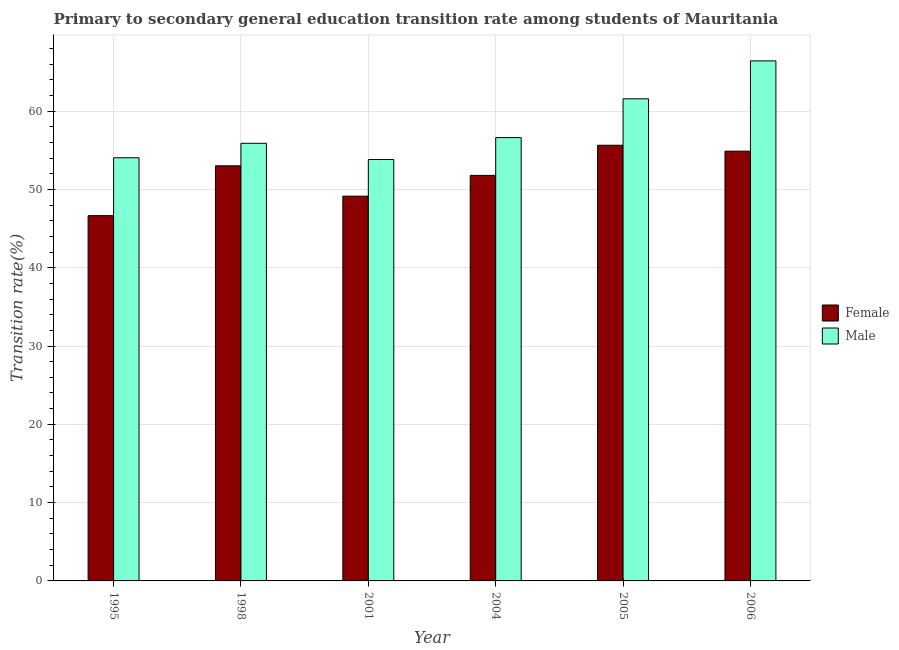How many different coloured bars are there?
Your response must be concise. 2. In how many cases, is the number of bars for a given year not equal to the number of legend labels?
Your answer should be very brief. 0. What is the transition rate among male students in 1998?
Your answer should be compact. 55.89. Across all years, what is the maximum transition rate among male students?
Provide a succinct answer. 66.41. Across all years, what is the minimum transition rate among female students?
Make the answer very short. 46.65. In which year was the transition rate among female students minimum?
Your response must be concise. 1995. What is the total transition rate among female students in the graph?
Provide a short and direct response. 311.11. What is the difference between the transition rate among female students in 2005 and that in 2006?
Keep it short and to the point. 0.76. What is the difference between the transition rate among female students in 2001 and the transition rate among male students in 1998?
Provide a short and direct response. -3.88. What is the average transition rate among female students per year?
Offer a terse response. 51.85. In how many years, is the transition rate among female students greater than 54 %?
Keep it short and to the point. 2. What is the ratio of the transition rate among male students in 1995 to that in 2005?
Provide a short and direct response. 0.88. What is the difference between the highest and the second highest transition rate among female students?
Provide a short and direct response. 0.76. What is the difference between the highest and the lowest transition rate among male students?
Your response must be concise. 12.59. What does the 2nd bar from the left in 2005 represents?
Provide a succinct answer. Male. What does the 2nd bar from the right in 2005 represents?
Offer a very short reply. Female. How many bars are there?
Offer a terse response. 12. What is the difference between two consecutive major ticks on the Y-axis?
Your answer should be very brief. 10. Does the graph contain any zero values?
Provide a succinct answer. No. How many legend labels are there?
Keep it short and to the point. 2. What is the title of the graph?
Your answer should be very brief. Primary to secondary general education transition rate among students of Mauritania. Does "Male labourers" appear as one of the legend labels in the graph?
Offer a terse response. No. What is the label or title of the Y-axis?
Your answer should be very brief. Transition rate(%). What is the Transition rate(%) of Female in 1995?
Offer a very short reply. 46.65. What is the Transition rate(%) in Male in 1995?
Provide a succinct answer. 54.04. What is the Transition rate(%) of Female in 1998?
Your answer should be very brief. 53.01. What is the Transition rate(%) in Male in 1998?
Provide a succinct answer. 55.89. What is the Transition rate(%) of Female in 2001?
Give a very brief answer. 49.14. What is the Transition rate(%) of Male in 2001?
Offer a terse response. 53.82. What is the Transition rate(%) of Female in 2004?
Your answer should be very brief. 51.79. What is the Transition rate(%) of Male in 2004?
Your answer should be compact. 56.62. What is the Transition rate(%) in Female in 2005?
Provide a succinct answer. 55.64. What is the Transition rate(%) of Male in 2005?
Provide a short and direct response. 61.57. What is the Transition rate(%) in Female in 2006?
Your response must be concise. 54.88. What is the Transition rate(%) in Male in 2006?
Your answer should be very brief. 66.41. Across all years, what is the maximum Transition rate(%) in Female?
Provide a succinct answer. 55.64. Across all years, what is the maximum Transition rate(%) in Male?
Your answer should be very brief. 66.41. Across all years, what is the minimum Transition rate(%) of Female?
Give a very brief answer. 46.65. Across all years, what is the minimum Transition rate(%) in Male?
Provide a short and direct response. 53.82. What is the total Transition rate(%) of Female in the graph?
Your answer should be very brief. 311.11. What is the total Transition rate(%) in Male in the graph?
Your answer should be very brief. 348.35. What is the difference between the Transition rate(%) of Female in 1995 and that in 1998?
Provide a succinct answer. -6.36. What is the difference between the Transition rate(%) in Male in 1995 and that in 1998?
Ensure brevity in your answer.  -1.85. What is the difference between the Transition rate(%) of Female in 1995 and that in 2001?
Your response must be concise. -2.49. What is the difference between the Transition rate(%) of Male in 1995 and that in 2001?
Ensure brevity in your answer.  0.22. What is the difference between the Transition rate(%) of Female in 1995 and that in 2004?
Offer a very short reply. -5.14. What is the difference between the Transition rate(%) of Male in 1995 and that in 2004?
Your answer should be very brief. -2.58. What is the difference between the Transition rate(%) in Female in 1995 and that in 2005?
Offer a terse response. -8.99. What is the difference between the Transition rate(%) of Male in 1995 and that in 2005?
Your answer should be compact. -7.53. What is the difference between the Transition rate(%) of Female in 1995 and that in 2006?
Give a very brief answer. -8.23. What is the difference between the Transition rate(%) in Male in 1995 and that in 2006?
Provide a short and direct response. -12.37. What is the difference between the Transition rate(%) of Female in 1998 and that in 2001?
Keep it short and to the point. 3.88. What is the difference between the Transition rate(%) in Male in 1998 and that in 2001?
Give a very brief answer. 2.07. What is the difference between the Transition rate(%) in Female in 1998 and that in 2004?
Make the answer very short. 1.22. What is the difference between the Transition rate(%) of Male in 1998 and that in 2004?
Provide a short and direct response. -0.73. What is the difference between the Transition rate(%) in Female in 1998 and that in 2005?
Your response must be concise. -2.63. What is the difference between the Transition rate(%) of Male in 1998 and that in 2005?
Your response must be concise. -5.68. What is the difference between the Transition rate(%) in Female in 1998 and that in 2006?
Your response must be concise. -1.87. What is the difference between the Transition rate(%) of Male in 1998 and that in 2006?
Make the answer very short. -10.52. What is the difference between the Transition rate(%) of Female in 2001 and that in 2004?
Offer a very short reply. -2.65. What is the difference between the Transition rate(%) in Male in 2001 and that in 2004?
Offer a very short reply. -2.8. What is the difference between the Transition rate(%) in Female in 2001 and that in 2005?
Your answer should be very brief. -6.5. What is the difference between the Transition rate(%) of Male in 2001 and that in 2005?
Keep it short and to the point. -7.75. What is the difference between the Transition rate(%) of Female in 2001 and that in 2006?
Provide a succinct answer. -5.75. What is the difference between the Transition rate(%) in Male in 2001 and that in 2006?
Keep it short and to the point. -12.59. What is the difference between the Transition rate(%) of Female in 2004 and that in 2005?
Offer a terse response. -3.85. What is the difference between the Transition rate(%) of Male in 2004 and that in 2005?
Give a very brief answer. -4.95. What is the difference between the Transition rate(%) in Female in 2004 and that in 2006?
Offer a terse response. -3.1. What is the difference between the Transition rate(%) in Male in 2004 and that in 2006?
Make the answer very short. -9.8. What is the difference between the Transition rate(%) in Female in 2005 and that in 2006?
Keep it short and to the point. 0.76. What is the difference between the Transition rate(%) in Male in 2005 and that in 2006?
Keep it short and to the point. -4.85. What is the difference between the Transition rate(%) in Female in 1995 and the Transition rate(%) in Male in 1998?
Provide a succinct answer. -9.24. What is the difference between the Transition rate(%) in Female in 1995 and the Transition rate(%) in Male in 2001?
Offer a very short reply. -7.17. What is the difference between the Transition rate(%) in Female in 1995 and the Transition rate(%) in Male in 2004?
Ensure brevity in your answer.  -9.97. What is the difference between the Transition rate(%) in Female in 1995 and the Transition rate(%) in Male in 2005?
Your answer should be very brief. -14.92. What is the difference between the Transition rate(%) of Female in 1995 and the Transition rate(%) of Male in 2006?
Offer a very short reply. -19.77. What is the difference between the Transition rate(%) in Female in 1998 and the Transition rate(%) in Male in 2001?
Ensure brevity in your answer.  -0.81. What is the difference between the Transition rate(%) of Female in 1998 and the Transition rate(%) of Male in 2004?
Provide a succinct answer. -3.6. What is the difference between the Transition rate(%) of Female in 1998 and the Transition rate(%) of Male in 2005?
Your answer should be very brief. -8.56. What is the difference between the Transition rate(%) of Female in 1998 and the Transition rate(%) of Male in 2006?
Keep it short and to the point. -13.4. What is the difference between the Transition rate(%) in Female in 2001 and the Transition rate(%) in Male in 2004?
Give a very brief answer. -7.48. What is the difference between the Transition rate(%) in Female in 2001 and the Transition rate(%) in Male in 2005?
Ensure brevity in your answer.  -12.43. What is the difference between the Transition rate(%) of Female in 2001 and the Transition rate(%) of Male in 2006?
Offer a terse response. -17.28. What is the difference between the Transition rate(%) of Female in 2004 and the Transition rate(%) of Male in 2005?
Your response must be concise. -9.78. What is the difference between the Transition rate(%) of Female in 2004 and the Transition rate(%) of Male in 2006?
Your answer should be compact. -14.63. What is the difference between the Transition rate(%) of Female in 2005 and the Transition rate(%) of Male in 2006?
Give a very brief answer. -10.78. What is the average Transition rate(%) of Female per year?
Make the answer very short. 51.85. What is the average Transition rate(%) of Male per year?
Your answer should be compact. 58.06. In the year 1995, what is the difference between the Transition rate(%) of Female and Transition rate(%) of Male?
Your answer should be very brief. -7.39. In the year 1998, what is the difference between the Transition rate(%) of Female and Transition rate(%) of Male?
Provide a succinct answer. -2.88. In the year 2001, what is the difference between the Transition rate(%) in Female and Transition rate(%) in Male?
Provide a short and direct response. -4.68. In the year 2004, what is the difference between the Transition rate(%) of Female and Transition rate(%) of Male?
Provide a short and direct response. -4.83. In the year 2005, what is the difference between the Transition rate(%) of Female and Transition rate(%) of Male?
Your answer should be compact. -5.93. In the year 2006, what is the difference between the Transition rate(%) of Female and Transition rate(%) of Male?
Offer a terse response. -11.53. What is the ratio of the Transition rate(%) of Female in 1995 to that in 1998?
Ensure brevity in your answer.  0.88. What is the ratio of the Transition rate(%) of Male in 1995 to that in 1998?
Your answer should be very brief. 0.97. What is the ratio of the Transition rate(%) in Female in 1995 to that in 2001?
Make the answer very short. 0.95. What is the ratio of the Transition rate(%) of Male in 1995 to that in 2001?
Provide a short and direct response. 1. What is the ratio of the Transition rate(%) of Female in 1995 to that in 2004?
Offer a very short reply. 0.9. What is the ratio of the Transition rate(%) of Male in 1995 to that in 2004?
Make the answer very short. 0.95. What is the ratio of the Transition rate(%) of Female in 1995 to that in 2005?
Your response must be concise. 0.84. What is the ratio of the Transition rate(%) in Male in 1995 to that in 2005?
Provide a succinct answer. 0.88. What is the ratio of the Transition rate(%) of Male in 1995 to that in 2006?
Keep it short and to the point. 0.81. What is the ratio of the Transition rate(%) of Female in 1998 to that in 2001?
Provide a short and direct response. 1.08. What is the ratio of the Transition rate(%) in Female in 1998 to that in 2004?
Provide a short and direct response. 1.02. What is the ratio of the Transition rate(%) in Male in 1998 to that in 2004?
Offer a very short reply. 0.99. What is the ratio of the Transition rate(%) of Female in 1998 to that in 2005?
Ensure brevity in your answer.  0.95. What is the ratio of the Transition rate(%) in Male in 1998 to that in 2005?
Your answer should be compact. 0.91. What is the ratio of the Transition rate(%) of Female in 1998 to that in 2006?
Provide a short and direct response. 0.97. What is the ratio of the Transition rate(%) of Male in 1998 to that in 2006?
Your response must be concise. 0.84. What is the ratio of the Transition rate(%) of Female in 2001 to that in 2004?
Provide a short and direct response. 0.95. What is the ratio of the Transition rate(%) in Male in 2001 to that in 2004?
Give a very brief answer. 0.95. What is the ratio of the Transition rate(%) in Female in 2001 to that in 2005?
Give a very brief answer. 0.88. What is the ratio of the Transition rate(%) in Male in 2001 to that in 2005?
Provide a short and direct response. 0.87. What is the ratio of the Transition rate(%) of Female in 2001 to that in 2006?
Keep it short and to the point. 0.9. What is the ratio of the Transition rate(%) in Male in 2001 to that in 2006?
Provide a succinct answer. 0.81. What is the ratio of the Transition rate(%) in Female in 2004 to that in 2005?
Your answer should be very brief. 0.93. What is the ratio of the Transition rate(%) of Male in 2004 to that in 2005?
Your response must be concise. 0.92. What is the ratio of the Transition rate(%) in Female in 2004 to that in 2006?
Your answer should be compact. 0.94. What is the ratio of the Transition rate(%) in Male in 2004 to that in 2006?
Give a very brief answer. 0.85. What is the ratio of the Transition rate(%) in Female in 2005 to that in 2006?
Offer a very short reply. 1.01. What is the ratio of the Transition rate(%) of Male in 2005 to that in 2006?
Provide a succinct answer. 0.93. What is the difference between the highest and the second highest Transition rate(%) in Female?
Offer a very short reply. 0.76. What is the difference between the highest and the second highest Transition rate(%) of Male?
Provide a short and direct response. 4.85. What is the difference between the highest and the lowest Transition rate(%) in Female?
Provide a short and direct response. 8.99. What is the difference between the highest and the lowest Transition rate(%) in Male?
Your response must be concise. 12.59. 